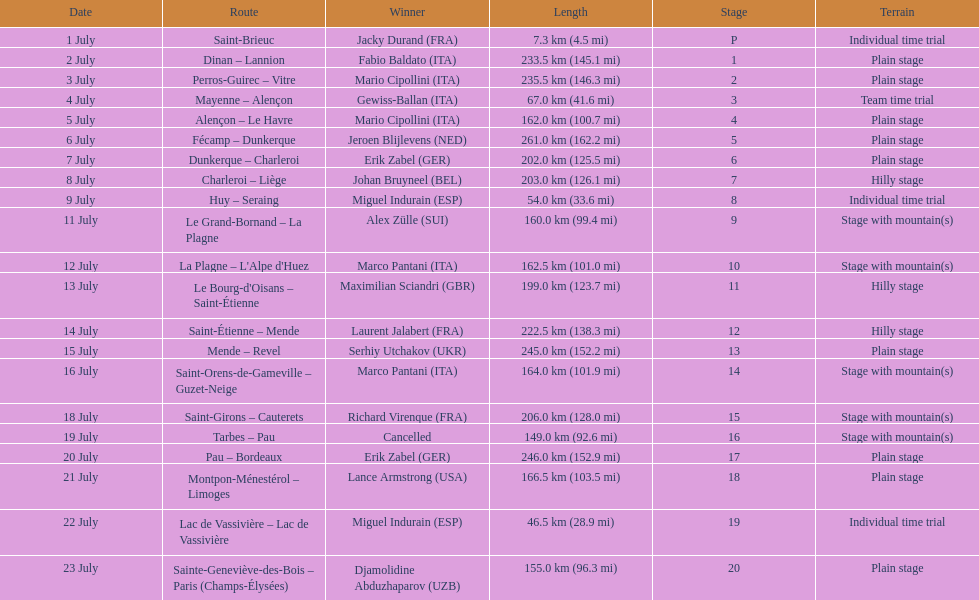Which routes were at least 100 km? Dinan - Lannion, Perros-Guirec - Vitre, Alençon - Le Havre, Fécamp - Dunkerque, Dunkerque - Charleroi, Charleroi - Liège, Le Grand-Bornand - La Plagne, La Plagne - L'Alpe d'Huez, Le Bourg-d'Oisans - Saint-Étienne, Saint-Étienne - Mende, Mende - Revel, Saint-Orens-de-Gameville - Guzet-Neige, Saint-Girons - Cauterets, Tarbes - Pau, Pau - Bordeaux, Montpon-Ménestérol - Limoges, Sainte-Geneviève-des-Bois - Paris (Champs-Élysées). 